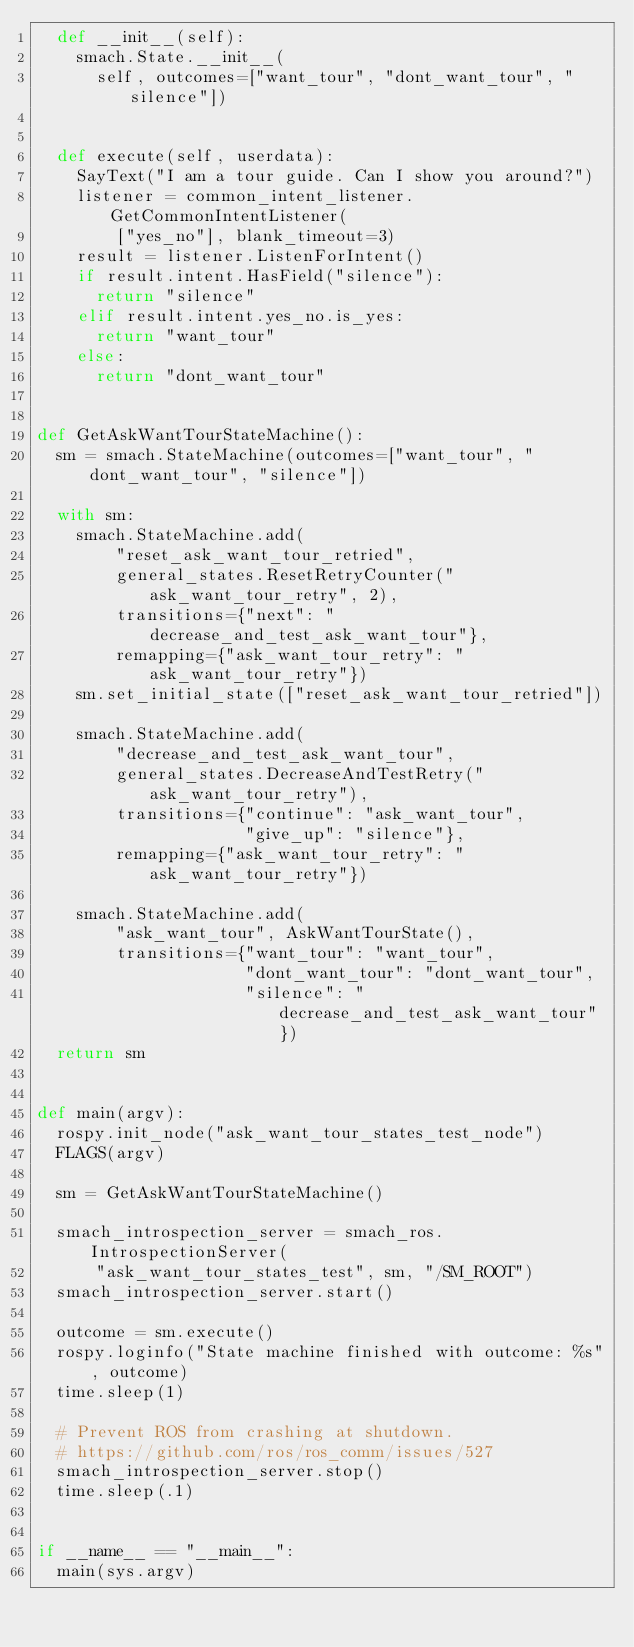<code> <loc_0><loc_0><loc_500><loc_500><_Python_>  def __init__(self):
    smach.State.__init__(
      self, outcomes=["want_tour", "dont_want_tour", "silence"])


  def execute(self, userdata):
    SayText("I am a tour guide. Can I show you around?")
    listener = common_intent_listener.GetCommonIntentListener(
        ["yes_no"], blank_timeout=3)
    result = listener.ListenForIntent()
    if result.intent.HasField("silence"):
      return "silence"
    elif result.intent.yes_no.is_yes:
      return "want_tour"
    else:
      return "dont_want_tour"


def GetAskWantTourStateMachine():
  sm = smach.StateMachine(outcomes=["want_tour", "dont_want_tour", "silence"])

  with sm:
    smach.StateMachine.add(
        "reset_ask_want_tour_retried",
        general_states.ResetRetryCounter("ask_want_tour_retry", 2),
        transitions={"next": "decrease_and_test_ask_want_tour"},
        remapping={"ask_want_tour_retry": "ask_want_tour_retry"})
    sm.set_initial_state(["reset_ask_want_tour_retried"])

    smach.StateMachine.add(
        "decrease_and_test_ask_want_tour",
        general_states.DecreaseAndTestRetry("ask_want_tour_retry"),
        transitions={"continue": "ask_want_tour",
                     "give_up": "silence"},
        remapping={"ask_want_tour_retry": "ask_want_tour_retry"})

    smach.StateMachine.add(
        "ask_want_tour", AskWantTourState(),
        transitions={"want_tour": "want_tour",
                     "dont_want_tour": "dont_want_tour",
                     "silence": "decrease_and_test_ask_want_tour"})
  return sm


def main(argv):
  rospy.init_node("ask_want_tour_states_test_node")
  FLAGS(argv)

  sm = GetAskWantTourStateMachine()

  smach_introspection_server = smach_ros.IntrospectionServer(
      "ask_want_tour_states_test", sm, "/SM_ROOT")
  smach_introspection_server.start()

  outcome = sm.execute()
  rospy.loginfo("State machine finished with outcome: %s", outcome)
  time.sleep(1)

  # Prevent ROS from crashing at shutdown.
  # https://github.com/ros/ros_comm/issues/527
  smach_introspection_server.stop()
  time.sleep(.1)


if __name__ == "__main__":
  main(sys.argv)
</code> 